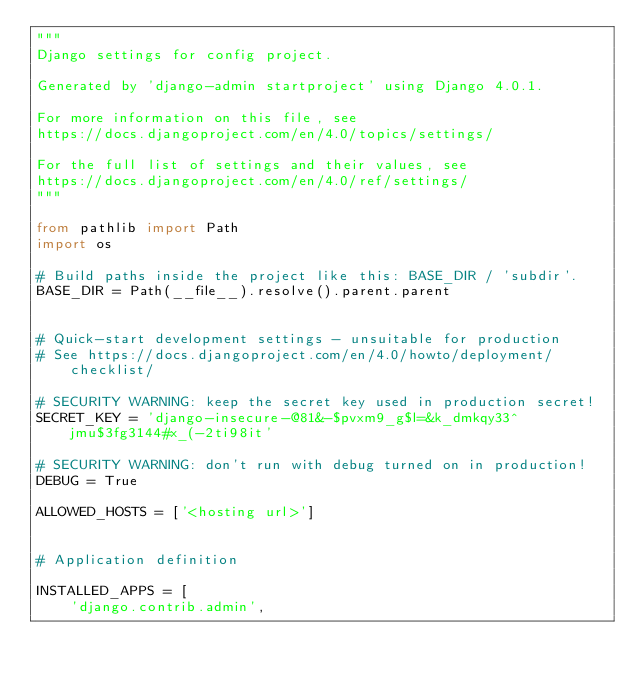Convert code to text. <code><loc_0><loc_0><loc_500><loc_500><_Python_>"""
Django settings for config project.

Generated by 'django-admin startproject' using Django 4.0.1.

For more information on this file, see
https://docs.djangoproject.com/en/4.0/topics/settings/

For the full list of settings and their values, see
https://docs.djangoproject.com/en/4.0/ref/settings/
"""

from pathlib import Path
import os

# Build paths inside the project like this: BASE_DIR / 'subdir'.
BASE_DIR = Path(__file__).resolve().parent.parent


# Quick-start development settings - unsuitable for production
# See https://docs.djangoproject.com/en/4.0/howto/deployment/checklist/

# SECURITY WARNING: keep the secret key used in production secret!
SECRET_KEY = 'django-insecure-@81&-$pvxm9_g$l=&k_dmkqy33^jmu$3fg3144#x_(-2ti98it'

# SECURITY WARNING: don't run with debug turned on in production!
DEBUG = True

ALLOWED_HOSTS = ['<hosting url>']


# Application definition

INSTALLED_APPS = [
    'django.contrib.admin',</code> 